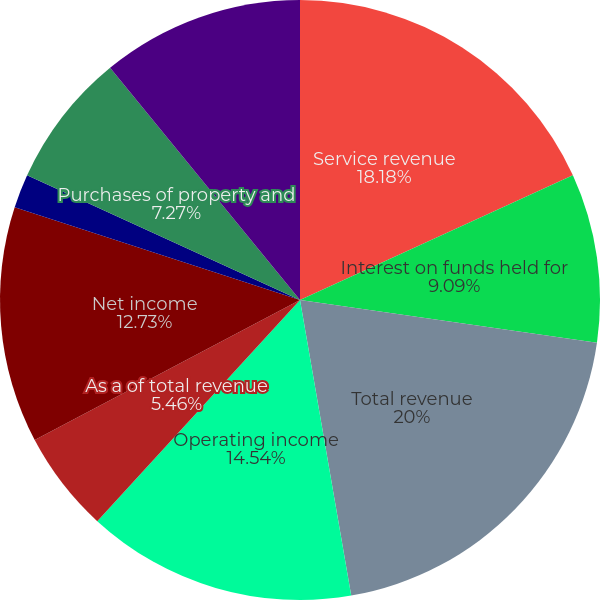Convert chart. <chart><loc_0><loc_0><loc_500><loc_500><pie_chart><fcel>Service revenue<fcel>Interest on funds held for<fcel>Total revenue<fcel>Operating income<fcel>As a of total revenue<fcel>Net income<fcel>Diluted earnings per share<fcel>Cash dividends per common<fcel>Purchases of property and<fcel>Cash and total corporate<nl><fcel>18.18%<fcel>9.09%<fcel>20.0%<fcel>14.54%<fcel>5.46%<fcel>12.73%<fcel>1.82%<fcel>0.0%<fcel>7.27%<fcel>10.91%<nl></chart> 